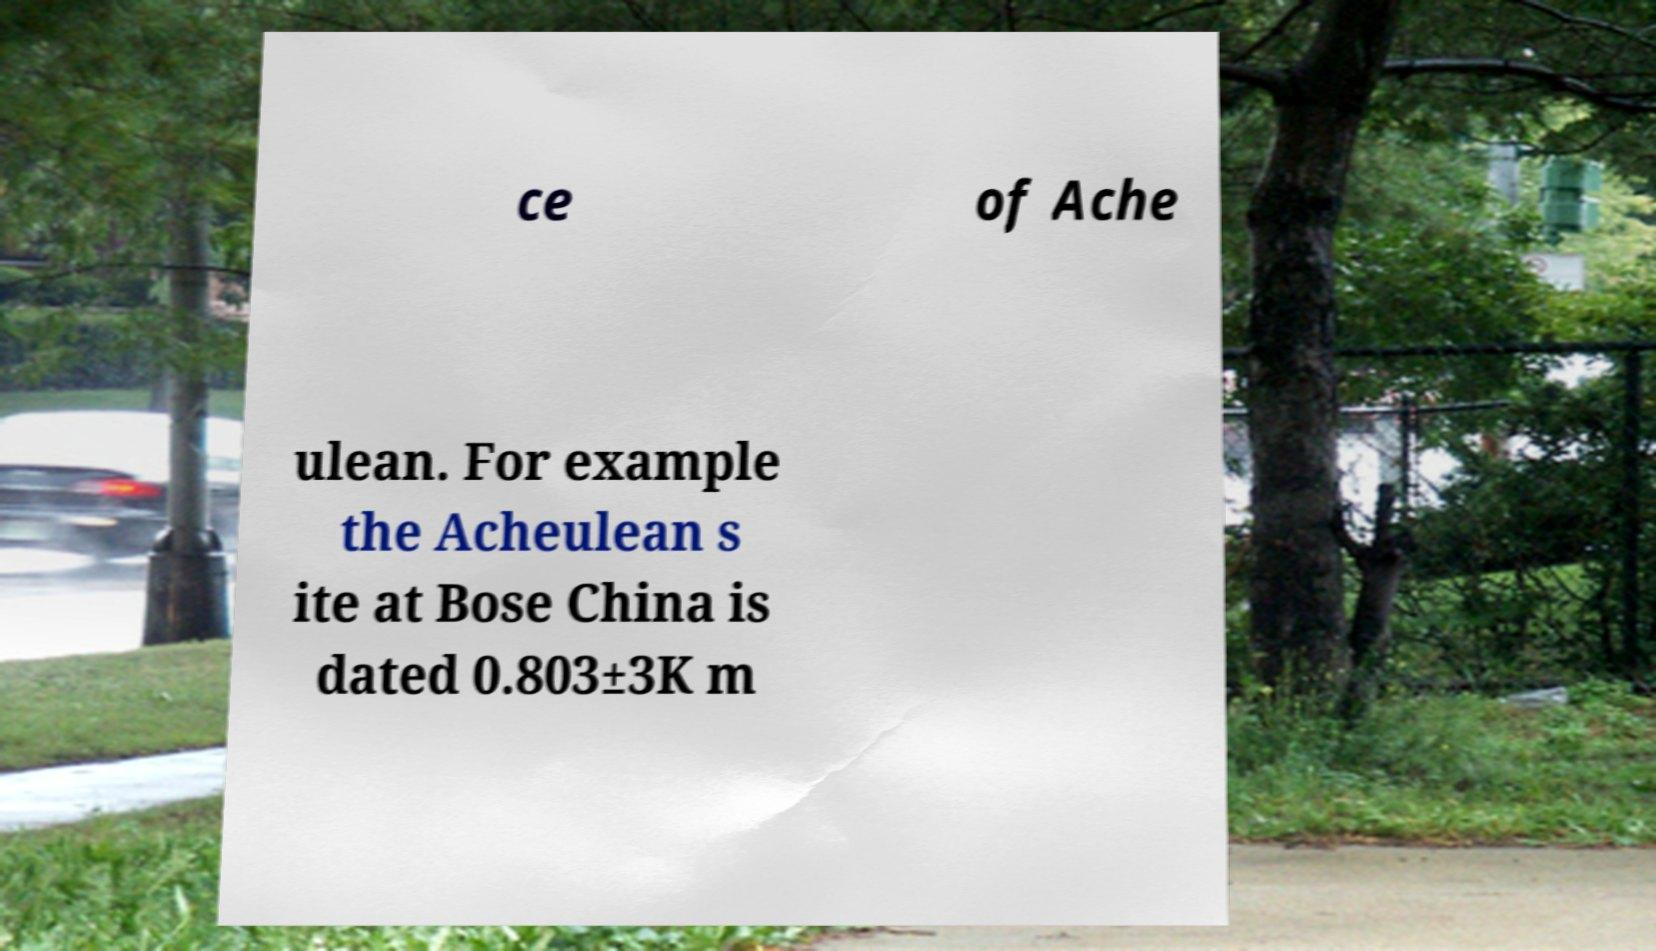Could you extract and type out the text from this image? ce of Ache ulean. For example the Acheulean s ite at Bose China is dated 0.803±3K m 